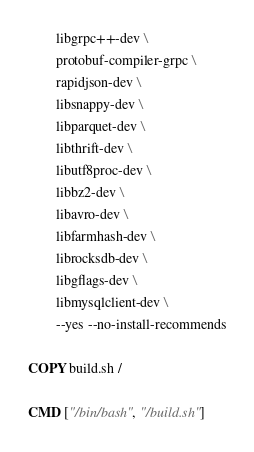<code> <loc_0><loc_0><loc_500><loc_500><_Dockerfile_>        libgrpc++-dev \
        protobuf-compiler-grpc \
        rapidjson-dev \
        libsnappy-dev \
        libparquet-dev \
        libthrift-dev \
        libutf8proc-dev \
        libbz2-dev \
        libavro-dev \
        libfarmhash-dev \
        librocksdb-dev \
        libgflags-dev \
        libmysqlclient-dev \
        --yes --no-install-recommends

COPY build.sh /

CMD ["/bin/bash", "/build.sh"]
</code> 